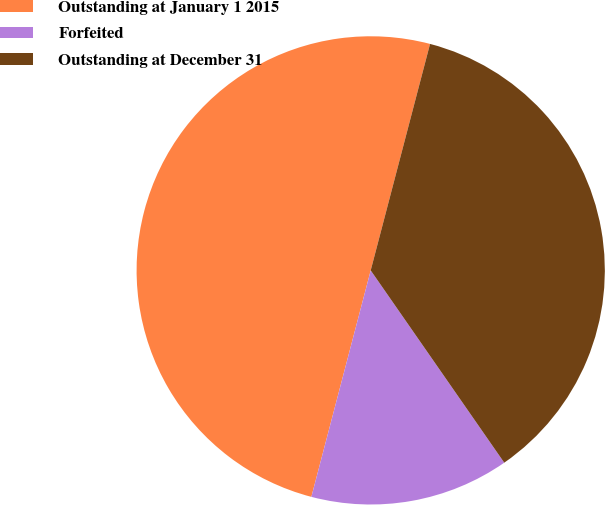Convert chart to OTSL. <chart><loc_0><loc_0><loc_500><loc_500><pie_chart><fcel>Outstanding at January 1 2015<fcel>Forfeited<fcel>Outstanding at December 31<nl><fcel>50.0%<fcel>13.74%<fcel>36.26%<nl></chart> 